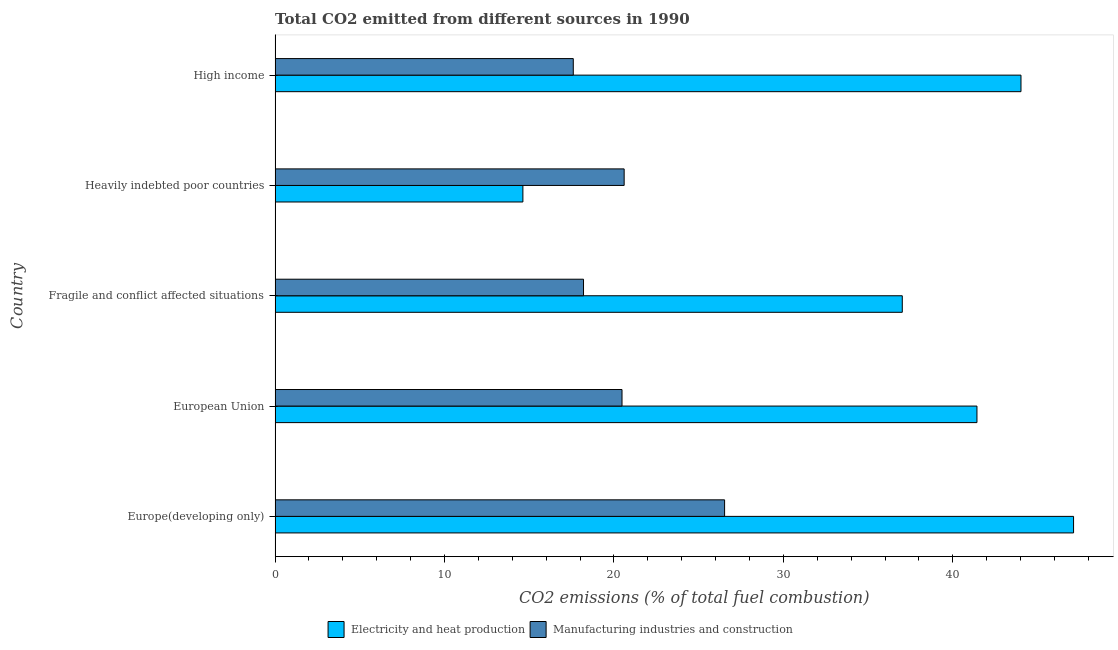How many groups of bars are there?
Your response must be concise. 5. Are the number of bars on each tick of the Y-axis equal?
Provide a succinct answer. Yes. What is the co2 emissions due to electricity and heat production in European Union?
Your answer should be compact. 41.43. Across all countries, what is the maximum co2 emissions due to electricity and heat production?
Provide a succinct answer. 47.13. Across all countries, what is the minimum co2 emissions due to electricity and heat production?
Offer a very short reply. 14.63. In which country was the co2 emissions due to manufacturing industries maximum?
Make the answer very short. Europe(developing only). In which country was the co2 emissions due to electricity and heat production minimum?
Your answer should be very brief. Heavily indebted poor countries. What is the total co2 emissions due to manufacturing industries in the graph?
Give a very brief answer. 103.41. What is the difference between the co2 emissions due to electricity and heat production in Europe(developing only) and that in High income?
Provide a short and direct response. 3.1. What is the difference between the co2 emissions due to manufacturing industries in Heavily indebted poor countries and the co2 emissions due to electricity and heat production in Fragile and conflict affected situations?
Provide a short and direct response. -16.42. What is the average co2 emissions due to electricity and heat production per country?
Your response must be concise. 36.84. What is the difference between the co2 emissions due to manufacturing industries and co2 emissions due to electricity and heat production in High income?
Your answer should be very brief. -26.42. In how many countries, is the co2 emissions due to electricity and heat production greater than 40 %?
Offer a terse response. 3. What is the ratio of the co2 emissions due to manufacturing industries in Europe(developing only) to that in European Union?
Provide a succinct answer. 1.3. Is the co2 emissions due to electricity and heat production in Fragile and conflict affected situations less than that in Heavily indebted poor countries?
Ensure brevity in your answer.  No. What is the difference between the highest and the second highest co2 emissions due to manufacturing industries?
Give a very brief answer. 5.93. What is the difference between the highest and the lowest co2 emissions due to electricity and heat production?
Keep it short and to the point. 32.5. In how many countries, is the co2 emissions due to electricity and heat production greater than the average co2 emissions due to electricity and heat production taken over all countries?
Provide a short and direct response. 4. Is the sum of the co2 emissions due to electricity and heat production in European Union and High income greater than the maximum co2 emissions due to manufacturing industries across all countries?
Your answer should be compact. Yes. What does the 1st bar from the top in European Union represents?
Your answer should be very brief. Manufacturing industries and construction. What does the 2nd bar from the bottom in Heavily indebted poor countries represents?
Provide a short and direct response. Manufacturing industries and construction. How many countries are there in the graph?
Provide a short and direct response. 5. What is the difference between two consecutive major ticks on the X-axis?
Provide a short and direct response. 10. Are the values on the major ticks of X-axis written in scientific E-notation?
Make the answer very short. No. Does the graph contain any zero values?
Give a very brief answer. No. Does the graph contain grids?
Your answer should be compact. No. Where does the legend appear in the graph?
Your answer should be compact. Bottom center. How many legend labels are there?
Your answer should be compact. 2. What is the title of the graph?
Keep it short and to the point. Total CO2 emitted from different sources in 1990. What is the label or title of the X-axis?
Give a very brief answer. CO2 emissions (% of total fuel combustion). What is the CO2 emissions (% of total fuel combustion) in Electricity and heat production in Europe(developing only)?
Offer a terse response. 47.13. What is the CO2 emissions (% of total fuel combustion) in Manufacturing industries and construction in Europe(developing only)?
Ensure brevity in your answer.  26.53. What is the CO2 emissions (% of total fuel combustion) of Electricity and heat production in European Union?
Your answer should be very brief. 41.43. What is the CO2 emissions (% of total fuel combustion) of Manufacturing industries and construction in European Union?
Provide a succinct answer. 20.48. What is the CO2 emissions (% of total fuel combustion) of Electricity and heat production in Fragile and conflict affected situations?
Make the answer very short. 37.02. What is the CO2 emissions (% of total fuel combustion) in Manufacturing industries and construction in Fragile and conflict affected situations?
Offer a very short reply. 18.2. What is the CO2 emissions (% of total fuel combustion) in Electricity and heat production in Heavily indebted poor countries?
Your answer should be very brief. 14.63. What is the CO2 emissions (% of total fuel combustion) of Manufacturing industries and construction in Heavily indebted poor countries?
Offer a terse response. 20.6. What is the CO2 emissions (% of total fuel combustion) of Electricity and heat production in High income?
Offer a terse response. 44.02. What is the CO2 emissions (% of total fuel combustion) of Manufacturing industries and construction in High income?
Your answer should be compact. 17.6. Across all countries, what is the maximum CO2 emissions (% of total fuel combustion) of Electricity and heat production?
Your answer should be very brief. 47.13. Across all countries, what is the maximum CO2 emissions (% of total fuel combustion) in Manufacturing industries and construction?
Provide a succinct answer. 26.53. Across all countries, what is the minimum CO2 emissions (% of total fuel combustion) in Electricity and heat production?
Make the answer very short. 14.63. Across all countries, what is the minimum CO2 emissions (% of total fuel combustion) in Manufacturing industries and construction?
Give a very brief answer. 17.6. What is the total CO2 emissions (% of total fuel combustion) of Electricity and heat production in the graph?
Give a very brief answer. 184.22. What is the total CO2 emissions (% of total fuel combustion) of Manufacturing industries and construction in the graph?
Give a very brief answer. 103.41. What is the difference between the CO2 emissions (% of total fuel combustion) in Electricity and heat production in Europe(developing only) and that in European Union?
Your response must be concise. 5.7. What is the difference between the CO2 emissions (% of total fuel combustion) in Manufacturing industries and construction in Europe(developing only) and that in European Union?
Ensure brevity in your answer.  6.05. What is the difference between the CO2 emissions (% of total fuel combustion) of Electricity and heat production in Europe(developing only) and that in Fragile and conflict affected situations?
Provide a succinct answer. 10.11. What is the difference between the CO2 emissions (% of total fuel combustion) of Manufacturing industries and construction in Europe(developing only) and that in Fragile and conflict affected situations?
Your answer should be compact. 8.33. What is the difference between the CO2 emissions (% of total fuel combustion) of Electricity and heat production in Europe(developing only) and that in Heavily indebted poor countries?
Provide a succinct answer. 32.5. What is the difference between the CO2 emissions (% of total fuel combustion) of Manufacturing industries and construction in Europe(developing only) and that in Heavily indebted poor countries?
Offer a very short reply. 5.93. What is the difference between the CO2 emissions (% of total fuel combustion) of Electricity and heat production in Europe(developing only) and that in High income?
Keep it short and to the point. 3.1. What is the difference between the CO2 emissions (% of total fuel combustion) of Manufacturing industries and construction in Europe(developing only) and that in High income?
Your answer should be very brief. 8.93. What is the difference between the CO2 emissions (% of total fuel combustion) of Electricity and heat production in European Union and that in Fragile and conflict affected situations?
Your answer should be compact. 4.41. What is the difference between the CO2 emissions (% of total fuel combustion) in Manufacturing industries and construction in European Union and that in Fragile and conflict affected situations?
Keep it short and to the point. 2.27. What is the difference between the CO2 emissions (% of total fuel combustion) of Electricity and heat production in European Union and that in Heavily indebted poor countries?
Make the answer very short. 26.8. What is the difference between the CO2 emissions (% of total fuel combustion) in Manufacturing industries and construction in European Union and that in Heavily indebted poor countries?
Keep it short and to the point. -0.13. What is the difference between the CO2 emissions (% of total fuel combustion) of Electricity and heat production in European Union and that in High income?
Make the answer very short. -2.6. What is the difference between the CO2 emissions (% of total fuel combustion) in Manufacturing industries and construction in European Union and that in High income?
Provide a succinct answer. 2.88. What is the difference between the CO2 emissions (% of total fuel combustion) of Electricity and heat production in Fragile and conflict affected situations and that in Heavily indebted poor countries?
Offer a terse response. 22.39. What is the difference between the CO2 emissions (% of total fuel combustion) in Manufacturing industries and construction in Fragile and conflict affected situations and that in Heavily indebted poor countries?
Keep it short and to the point. -2.4. What is the difference between the CO2 emissions (% of total fuel combustion) in Electricity and heat production in Fragile and conflict affected situations and that in High income?
Give a very brief answer. -7.01. What is the difference between the CO2 emissions (% of total fuel combustion) in Manufacturing industries and construction in Fragile and conflict affected situations and that in High income?
Offer a very short reply. 0.6. What is the difference between the CO2 emissions (% of total fuel combustion) of Electricity and heat production in Heavily indebted poor countries and that in High income?
Your answer should be compact. -29.4. What is the difference between the CO2 emissions (% of total fuel combustion) of Manufacturing industries and construction in Heavily indebted poor countries and that in High income?
Keep it short and to the point. 3. What is the difference between the CO2 emissions (% of total fuel combustion) in Electricity and heat production in Europe(developing only) and the CO2 emissions (% of total fuel combustion) in Manufacturing industries and construction in European Union?
Offer a terse response. 26.65. What is the difference between the CO2 emissions (% of total fuel combustion) in Electricity and heat production in Europe(developing only) and the CO2 emissions (% of total fuel combustion) in Manufacturing industries and construction in Fragile and conflict affected situations?
Provide a short and direct response. 28.92. What is the difference between the CO2 emissions (% of total fuel combustion) in Electricity and heat production in Europe(developing only) and the CO2 emissions (% of total fuel combustion) in Manufacturing industries and construction in Heavily indebted poor countries?
Offer a very short reply. 26.52. What is the difference between the CO2 emissions (% of total fuel combustion) of Electricity and heat production in Europe(developing only) and the CO2 emissions (% of total fuel combustion) of Manufacturing industries and construction in High income?
Ensure brevity in your answer.  29.53. What is the difference between the CO2 emissions (% of total fuel combustion) in Electricity and heat production in European Union and the CO2 emissions (% of total fuel combustion) in Manufacturing industries and construction in Fragile and conflict affected situations?
Provide a short and direct response. 23.22. What is the difference between the CO2 emissions (% of total fuel combustion) in Electricity and heat production in European Union and the CO2 emissions (% of total fuel combustion) in Manufacturing industries and construction in Heavily indebted poor countries?
Your answer should be compact. 20.82. What is the difference between the CO2 emissions (% of total fuel combustion) in Electricity and heat production in European Union and the CO2 emissions (% of total fuel combustion) in Manufacturing industries and construction in High income?
Give a very brief answer. 23.83. What is the difference between the CO2 emissions (% of total fuel combustion) in Electricity and heat production in Fragile and conflict affected situations and the CO2 emissions (% of total fuel combustion) in Manufacturing industries and construction in Heavily indebted poor countries?
Provide a succinct answer. 16.42. What is the difference between the CO2 emissions (% of total fuel combustion) in Electricity and heat production in Fragile and conflict affected situations and the CO2 emissions (% of total fuel combustion) in Manufacturing industries and construction in High income?
Make the answer very short. 19.42. What is the difference between the CO2 emissions (% of total fuel combustion) of Electricity and heat production in Heavily indebted poor countries and the CO2 emissions (% of total fuel combustion) of Manufacturing industries and construction in High income?
Give a very brief answer. -2.97. What is the average CO2 emissions (% of total fuel combustion) in Electricity and heat production per country?
Offer a terse response. 36.84. What is the average CO2 emissions (% of total fuel combustion) of Manufacturing industries and construction per country?
Offer a very short reply. 20.68. What is the difference between the CO2 emissions (% of total fuel combustion) of Electricity and heat production and CO2 emissions (% of total fuel combustion) of Manufacturing industries and construction in Europe(developing only)?
Offer a terse response. 20.6. What is the difference between the CO2 emissions (% of total fuel combustion) of Electricity and heat production and CO2 emissions (% of total fuel combustion) of Manufacturing industries and construction in European Union?
Keep it short and to the point. 20.95. What is the difference between the CO2 emissions (% of total fuel combustion) of Electricity and heat production and CO2 emissions (% of total fuel combustion) of Manufacturing industries and construction in Fragile and conflict affected situations?
Make the answer very short. 18.81. What is the difference between the CO2 emissions (% of total fuel combustion) in Electricity and heat production and CO2 emissions (% of total fuel combustion) in Manufacturing industries and construction in Heavily indebted poor countries?
Make the answer very short. -5.98. What is the difference between the CO2 emissions (% of total fuel combustion) in Electricity and heat production and CO2 emissions (% of total fuel combustion) in Manufacturing industries and construction in High income?
Offer a very short reply. 26.42. What is the ratio of the CO2 emissions (% of total fuel combustion) of Electricity and heat production in Europe(developing only) to that in European Union?
Ensure brevity in your answer.  1.14. What is the ratio of the CO2 emissions (% of total fuel combustion) in Manufacturing industries and construction in Europe(developing only) to that in European Union?
Your answer should be very brief. 1.3. What is the ratio of the CO2 emissions (% of total fuel combustion) in Electricity and heat production in Europe(developing only) to that in Fragile and conflict affected situations?
Your response must be concise. 1.27. What is the ratio of the CO2 emissions (% of total fuel combustion) of Manufacturing industries and construction in Europe(developing only) to that in Fragile and conflict affected situations?
Provide a succinct answer. 1.46. What is the ratio of the CO2 emissions (% of total fuel combustion) in Electricity and heat production in Europe(developing only) to that in Heavily indebted poor countries?
Offer a terse response. 3.22. What is the ratio of the CO2 emissions (% of total fuel combustion) in Manufacturing industries and construction in Europe(developing only) to that in Heavily indebted poor countries?
Keep it short and to the point. 1.29. What is the ratio of the CO2 emissions (% of total fuel combustion) in Electricity and heat production in Europe(developing only) to that in High income?
Give a very brief answer. 1.07. What is the ratio of the CO2 emissions (% of total fuel combustion) of Manufacturing industries and construction in Europe(developing only) to that in High income?
Your answer should be compact. 1.51. What is the ratio of the CO2 emissions (% of total fuel combustion) of Electricity and heat production in European Union to that in Fragile and conflict affected situations?
Provide a succinct answer. 1.12. What is the ratio of the CO2 emissions (% of total fuel combustion) of Manufacturing industries and construction in European Union to that in Fragile and conflict affected situations?
Your answer should be very brief. 1.12. What is the ratio of the CO2 emissions (% of total fuel combustion) in Electricity and heat production in European Union to that in Heavily indebted poor countries?
Offer a very short reply. 2.83. What is the ratio of the CO2 emissions (% of total fuel combustion) of Manufacturing industries and construction in European Union to that in Heavily indebted poor countries?
Provide a short and direct response. 0.99. What is the ratio of the CO2 emissions (% of total fuel combustion) in Electricity and heat production in European Union to that in High income?
Give a very brief answer. 0.94. What is the ratio of the CO2 emissions (% of total fuel combustion) of Manufacturing industries and construction in European Union to that in High income?
Keep it short and to the point. 1.16. What is the ratio of the CO2 emissions (% of total fuel combustion) of Electricity and heat production in Fragile and conflict affected situations to that in Heavily indebted poor countries?
Provide a succinct answer. 2.53. What is the ratio of the CO2 emissions (% of total fuel combustion) in Manufacturing industries and construction in Fragile and conflict affected situations to that in Heavily indebted poor countries?
Offer a terse response. 0.88. What is the ratio of the CO2 emissions (% of total fuel combustion) in Electricity and heat production in Fragile and conflict affected situations to that in High income?
Offer a terse response. 0.84. What is the ratio of the CO2 emissions (% of total fuel combustion) in Manufacturing industries and construction in Fragile and conflict affected situations to that in High income?
Offer a terse response. 1.03. What is the ratio of the CO2 emissions (% of total fuel combustion) in Electricity and heat production in Heavily indebted poor countries to that in High income?
Give a very brief answer. 0.33. What is the ratio of the CO2 emissions (% of total fuel combustion) in Manufacturing industries and construction in Heavily indebted poor countries to that in High income?
Your answer should be compact. 1.17. What is the difference between the highest and the second highest CO2 emissions (% of total fuel combustion) in Electricity and heat production?
Make the answer very short. 3.1. What is the difference between the highest and the second highest CO2 emissions (% of total fuel combustion) of Manufacturing industries and construction?
Offer a very short reply. 5.93. What is the difference between the highest and the lowest CO2 emissions (% of total fuel combustion) of Electricity and heat production?
Provide a short and direct response. 32.5. What is the difference between the highest and the lowest CO2 emissions (% of total fuel combustion) in Manufacturing industries and construction?
Provide a short and direct response. 8.93. 